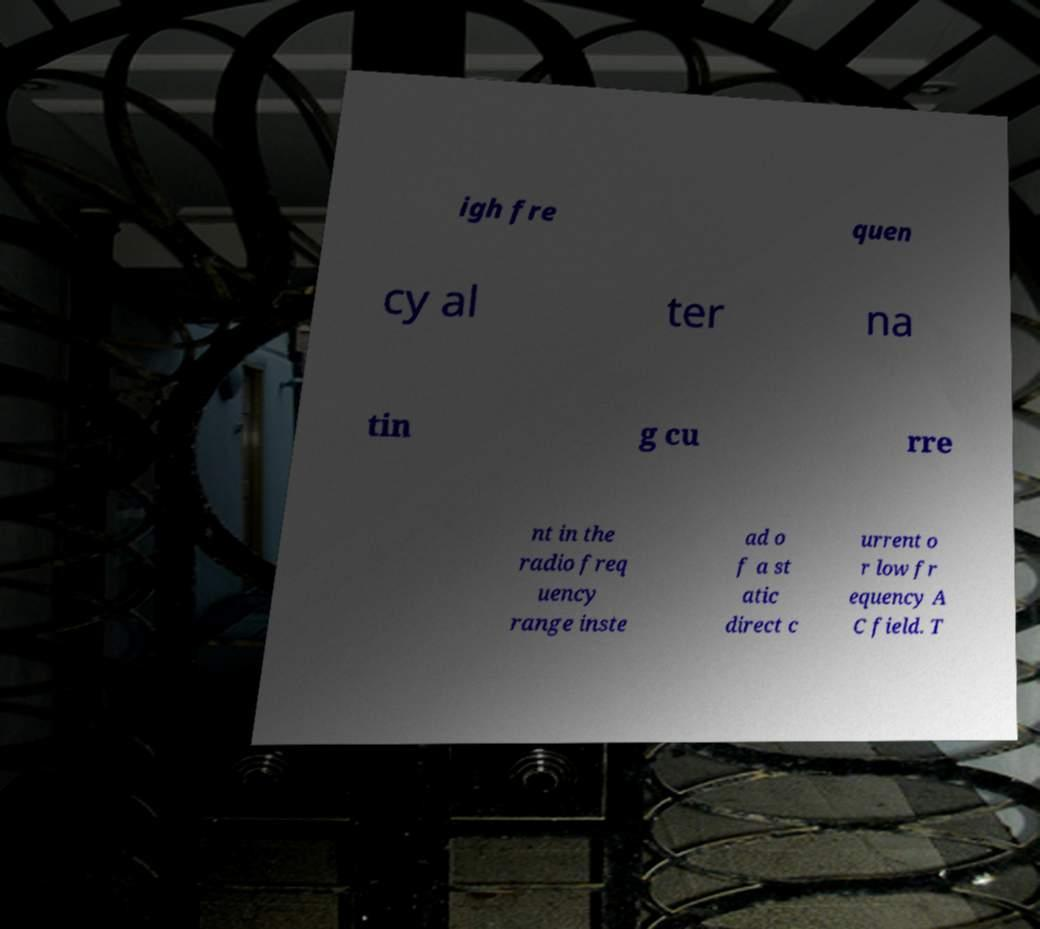Please identify and transcribe the text found in this image. igh fre quen cy al ter na tin g cu rre nt in the radio freq uency range inste ad o f a st atic direct c urrent o r low fr equency A C field. T 